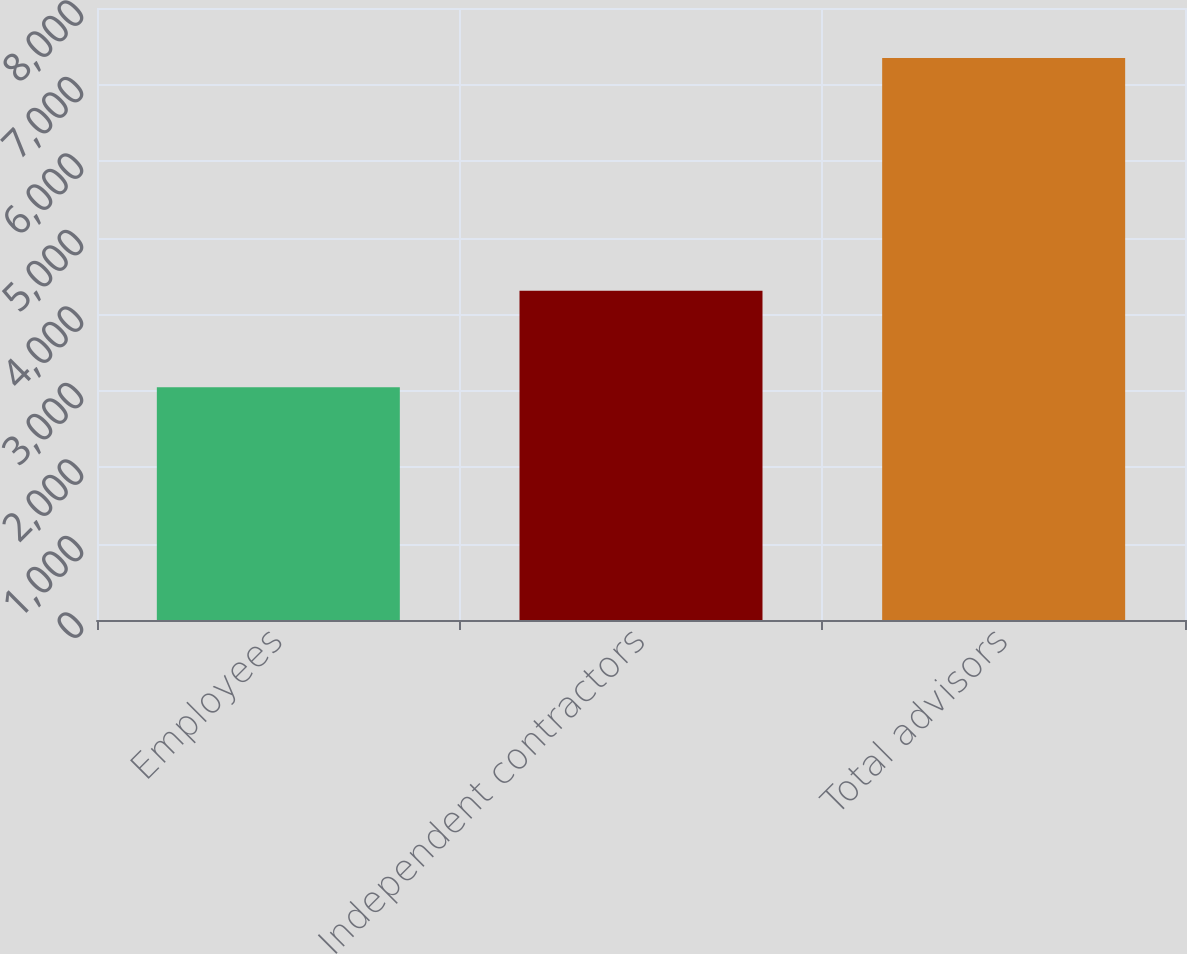Convert chart. <chart><loc_0><loc_0><loc_500><loc_500><bar_chart><fcel>Employees<fcel>Independent contractors<fcel>Total advisors<nl><fcel>3041<fcel>4305<fcel>7346<nl></chart> 